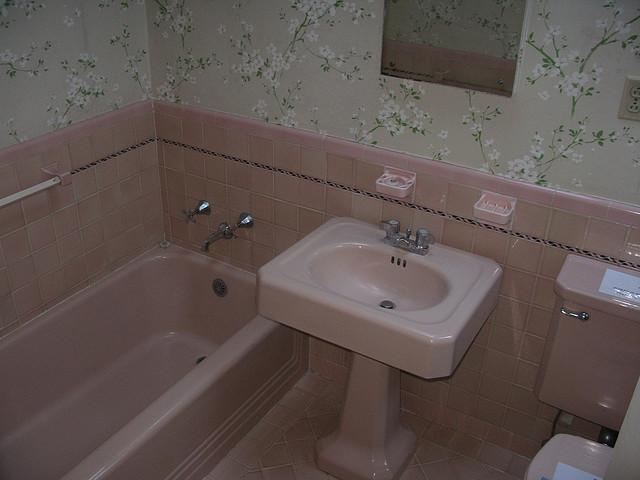Are the walls of this bathroom finished?
Write a very short answer. Yes. What do people do in here?
Answer briefly. Bathe. What are the two pink things above the sink?
Quick response, please. Soap dishes. What large object is situated in between the toilet and the bathtub?
Short answer required. Sink. IS this a modern bathroom?
Write a very short answer. No. What is the color of the sink?
Quick response, please. White. 